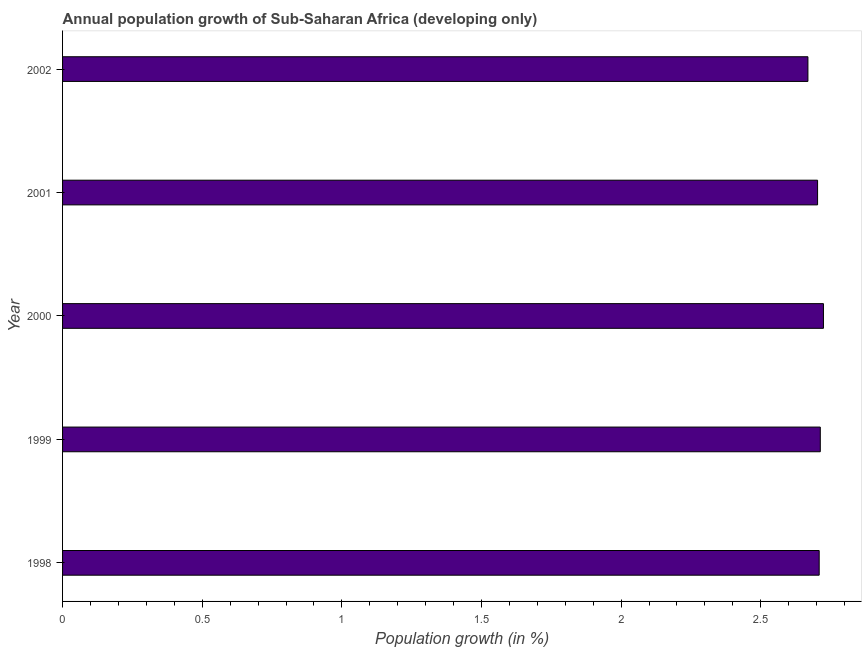Does the graph contain any zero values?
Your response must be concise. No. What is the title of the graph?
Make the answer very short. Annual population growth of Sub-Saharan Africa (developing only). What is the label or title of the X-axis?
Your answer should be compact. Population growth (in %). What is the label or title of the Y-axis?
Your answer should be compact. Year. What is the population growth in 2001?
Offer a terse response. 2.7. Across all years, what is the maximum population growth?
Provide a short and direct response. 2.72. Across all years, what is the minimum population growth?
Give a very brief answer. 2.67. In which year was the population growth maximum?
Give a very brief answer. 2000. What is the sum of the population growth?
Keep it short and to the point. 13.52. What is the difference between the population growth in 2000 and 2002?
Ensure brevity in your answer.  0.06. What is the average population growth per year?
Your answer should be compact. 2.7. What is the median population growth?
Provide a succinct answer. 2.71. In how many years, is the population growth greater than 1.6 %?
Offer a very short reply. 5. What is the ratio of the population growth in 1999 to that in 2000?
Make the answer very short. 1. Is the difference between the population growth in 1998 and 2000 greater than the difference between any two years?
Offer a terse response. No. What is the difference between the highest and the second highest population growth?
Your response must be concise. 0.01. Is the sum of the population growth in 1998 and 2000 greater than the maximum population growth across all years?
Offer a terse response. Yes. What is the difference between the highest and the lowest population growth?
Offer a very short reply. 0.06. In how many years, is the population growth greater than the average population growth taken over all years?
Provide a succinct answer. 3. What is the difference between two consecutive major ticks on the X-axis?
Make the answer very short. 0.5. What is the Population growth (in %) of 1998?
Offer a terse response. 2.71. What is the Population growth (in %) in 1999?
Offer a very short reply. 2.71. What is the Population growth (in %) of 2000?
Your answer should be compact. 2.72. What is the Population growth (in %) in 2001?
Your response must be concise. 2.7. What is the Population growth (in %) of 2002?
Offer a very short reply. 2.67. What is the difference between the Population growth (in %) in 1998 and 1999?
Your response must be concise. -0. What is the difference between the Population growth (in %) in 1998 and 2000?
Your answer should be very brief. -0.02. What is the difference between the Population growth (in %) in 1998 and 2001?
Offer a terse response. 0.01. What is the difference between the Population growth (in %) in 1998 and 2002?
Keep it short and to the point. 0.04. What is the difference between the Population growth (in %) in 1999 and 2000?
Provide a short and direct response. -0.01. What is the difference between the Population growth (in %) in 1999 and 2001?
Your response must be concise. 0.01. What is the difference between the Population growth (in %) in 1999 and 2002?
Your answer should be very brief. 0.04. What is the difference between the Population growth (in %) in 2000 and 2001?
Your response must be concise. 0.02. What is the difference between the Population growth (in %) in 2000 and 2002?
Your answer should be very brief. 0.06. What is the difference between the Population growth (in %) in 2001 and 2002?
Offer a very short reply. 0.03. What is the ratio of the Population growth (in %) in 1998 to that in 1999?
Make the answer very short. 1. What is the ratio of the Population growth (in %) in 1998 to that in 2002?
Your response must be concise. 1.01. What is the ratio of the Population growth (in %) in 1999 to that in 2000?
Give a very brief answer. 1. What is the ratio of the Population growth (in %) in 1999 to that in 2001?
Give a very brief answer. 1. What is the ratio of the Population growth (in %) in 1999 to that in 2002?
Provide a succinct answer. 1.02. What is the ratio of the Population growth (in %) in 2000 to that in 2002?
Your answer should be very brief. 1.02. 